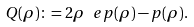Convert formula to latex. <formula><loc_0><loc_0><loc_500><loc_500>Q ( \rho ) \colon = 2 \rho \ e p ( \rho ) - p ( \rho ) .</formula> 